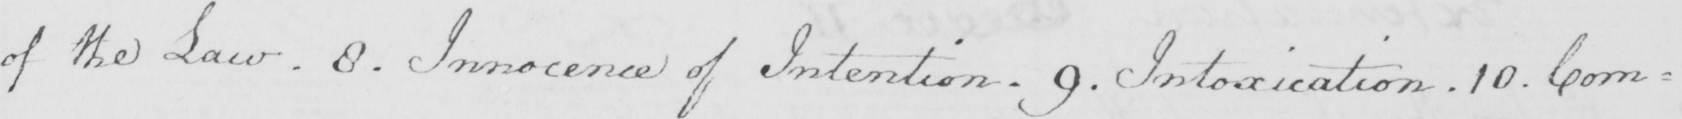Please provide the text content of this handwritten line. of the Law . 8 . Innocence of Intention . 9 . Intoxication . 10 . Com= 